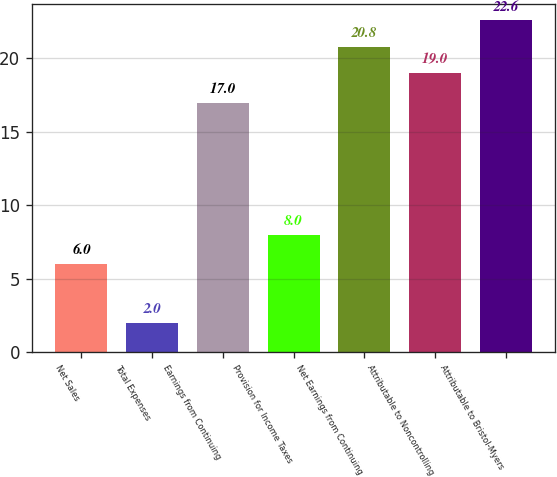Convert chart to OTSL. <chart><loc_0><loc_0><loc_500><loc_500><bar_chart><fcel>Net Sales<fcel>Total Expenses<fcel>Earnings from Continuing<fcel>Provision for Income Taxes<fcel>Net Earnings from Continuing<fcel>Attributable to Noncontrolling<fcel>Attributable to Bristol-Myers<nl><fcel>6<fcel>2<fcel>17<fcel>8<fcel>20.8<fcel>19<fcel>22.6<nl></chart> 